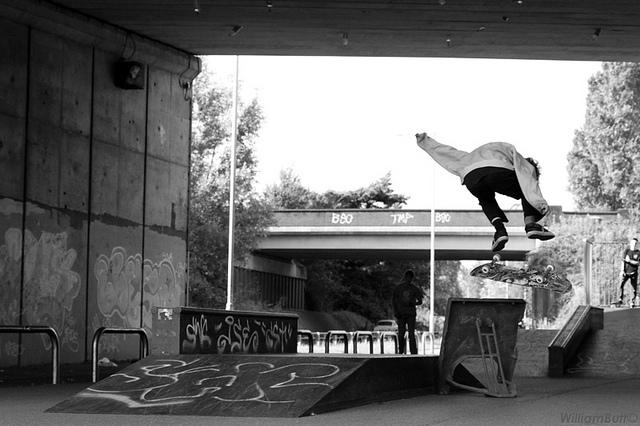Is the skateboard touching the ground?
Be succinct. No. Is this picture colored?
Short answer required. No. Is the guy flying?
Answer briefly. No. 